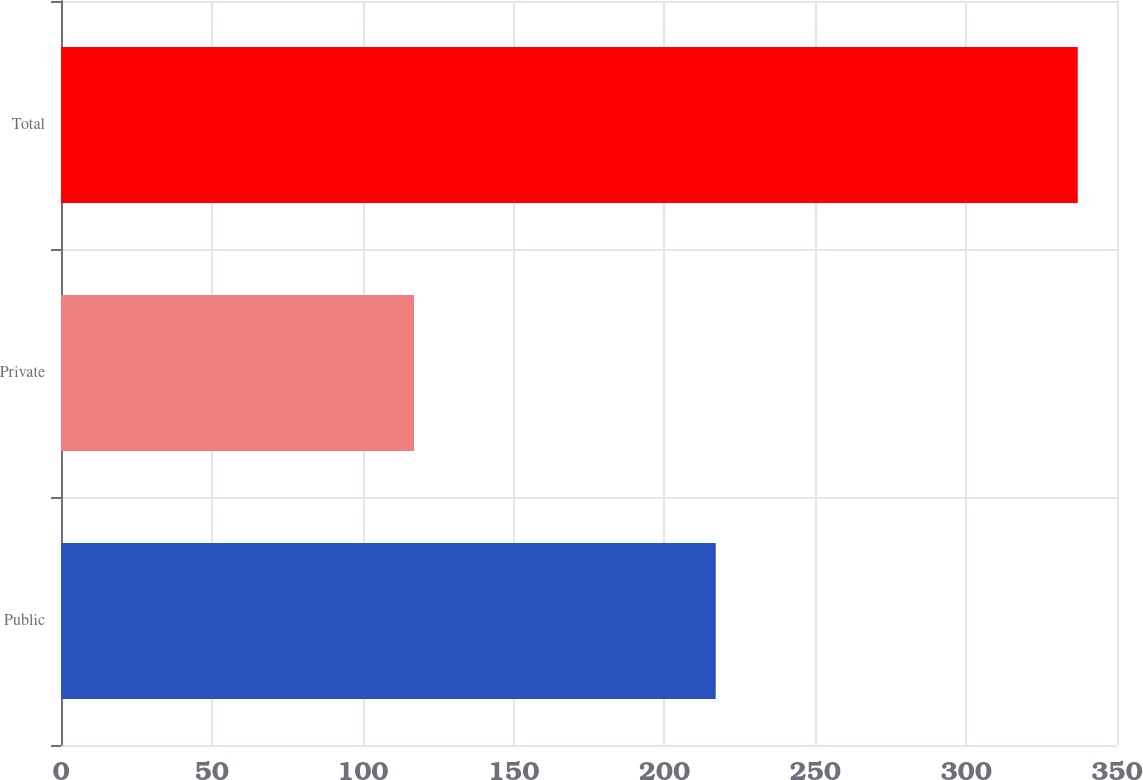<chart> <loc_0><loc_0><loc_500><loc_500><bar_chart><fcel>Public<fcel>Private<fcel>Total<nl><fcel>217<fcel>117<fcel>337<nl></chart> 